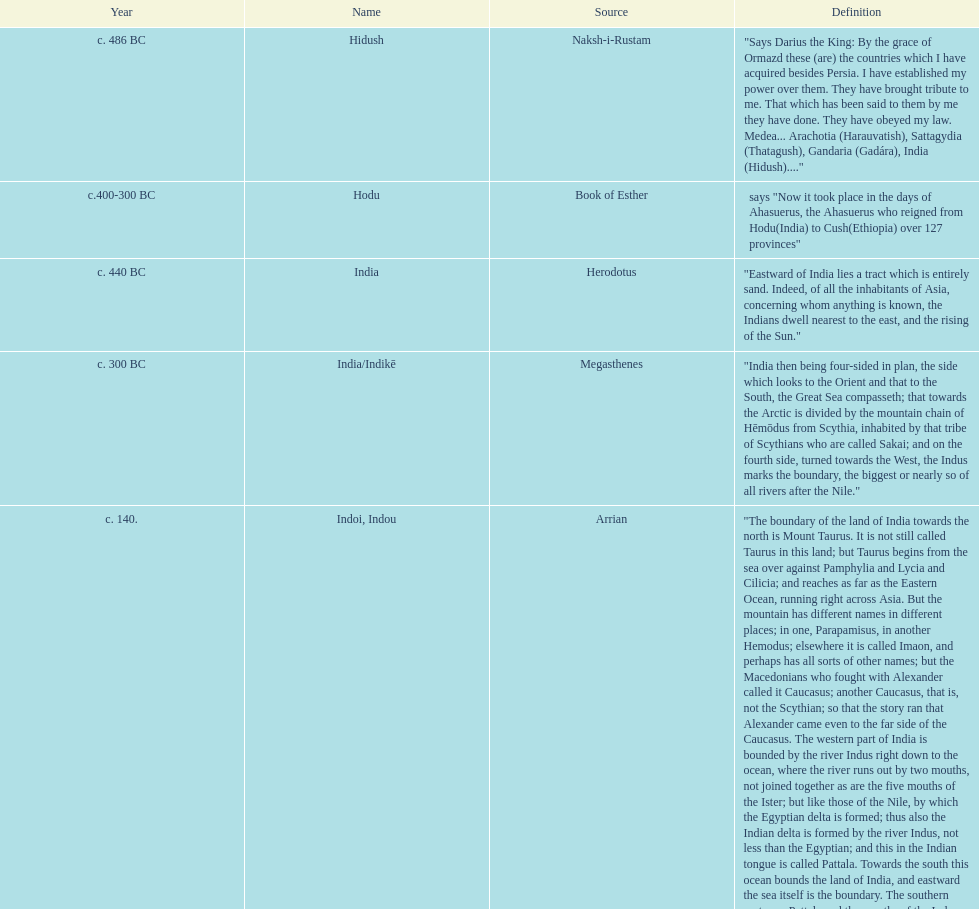What was the state's name before being labeled as hodu in the book of esther? Hidush. 